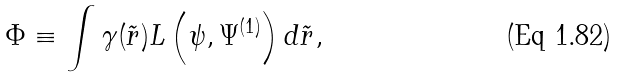<formula> <loc_0><loc_0><loc_500><loc_500>\Phi \equiv \int \gamma ( \tilde { r } ) L \left ( \psi , \Psi ^ { ( 1 ) } \right ) d \tilde { r } ,</formula> 